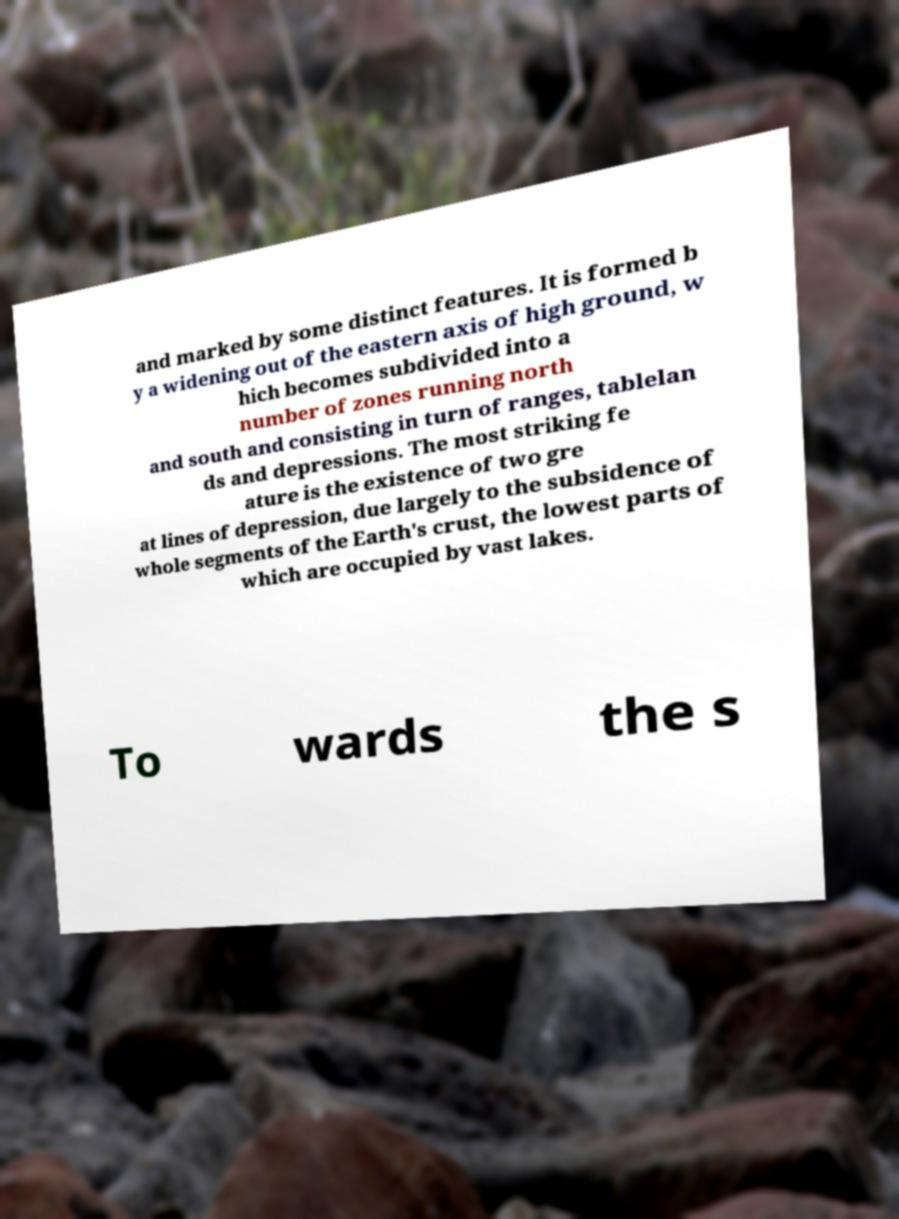Can you read and provide the text displayed in the image?This photo seems to have some interesting text. Can you extract and type it out for me? and marked by some distinct features. It is formed b y a widening out of the eastern axis of high ground, w hich becomes subdivided into a number of zones running north and south and consisting in turn of ranges, tablelan ds and depressions. The most striking fe ature is the existence of two gre at lines of depression, due largely to the subsidence of whole segments of the Earth's crust, the lowest parts of which are occupied by vast lakes. To wards the s 